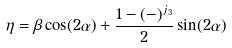<formula> <loc_0><loc_0><loc_500><loc_500>\eta = \beta \cos ( 2 \alpha ) + \frac { 1 - ( - ) ^ { j _ { 3 } } } { 2 } \sin ( 2 \alpha )</formula> 